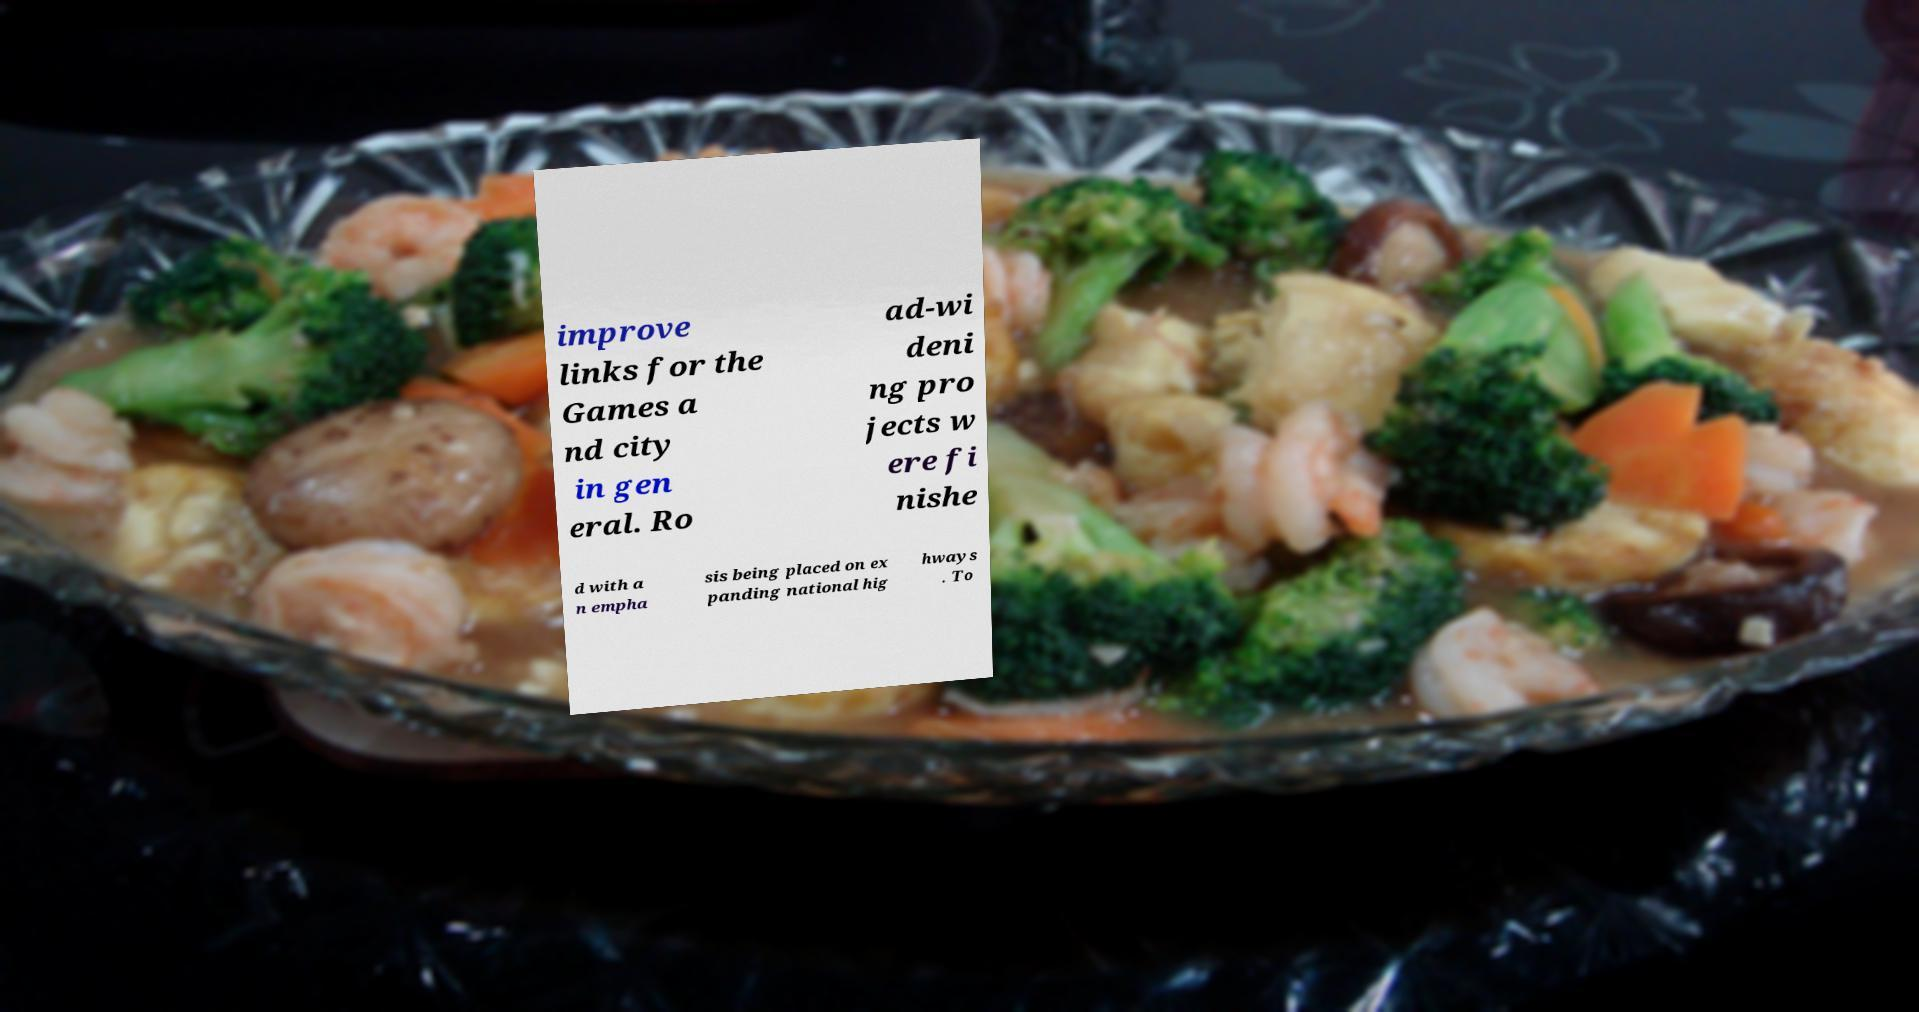Please identify and transcribe the text found in this image. improve links for the Games a nd city in gen eral. Ro ad-wi deni ng pro jects w ere fi nishe d with a n empha sis being placed on ex panding national hig hways . To 